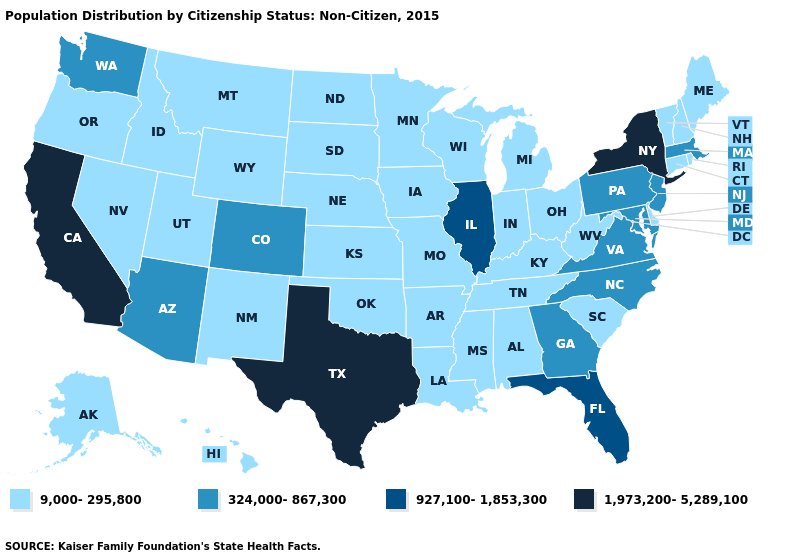Name the states that have a value in the range 9,000-295,800?
Be succinct. Alabama, Alaska, Arkansas, Connecticut, Delaware, Hawaii, Idaho, Indiana, Iowa, Kansas, Kentucky, Louisiana, Maine, Michigan, Minnesota, Mississippi, Missouri, Montana, Nebraska, Nevada, New Hampshire, New Mexico, North Dakota, Ohio, Oklahoma, Oregon, Rhode Island, South Carolina, South Dakota, Tennessee, Utah, Vermont, West Virginia, Wisconsin, Wyoming. Does Colorado have the same value as Arkansas?
Keep it brief. No. Which states have the highest value in the USA?
Keep it brief. California, New York, Texas. Does Pennsylvania have a higher value than Colorado?
Answer briefly. No. Name the states that have a value in the range 324,000-867,300?
Be succinct. Arizona, Colorado, Georgia, Maryland, Massachusetts, New Jersey, North Carolina, Pennsylvania, Virginia, Washington. Name the states that have a value in the range 9,000-295,800?
Keep it brief. Alabama, Alaska, Arkansas, Connecticut, Delaware, Hawaii, Idaho, Indiana, Iowa, Kansas, Kentucky, Louisiana, Maine, Michigan, Minnesota, Mississippi, Missouri, Montana, Nebraska, Nevada, New Hampshire, New Mexico, North Dakota, Ohio, Oklahoma, Oregon, Rhode Island, South Carolina, South Dakota, Tennessee, Utah, Vermont, West Virginia, Wisconsin, Wyoming. Name the states that have a value in the range 1,973,200-5,289,100?
Concise answer only. California, New York, Texas. Does Illinois have the lowest value in the MidWest?
Short answer required. No. Is the legend a continuous bar?
Write a very short answer. No. Does North Carolina have the lowest value in the USA?
Give a very brief answer. No. Name the states that have a value in the range 324,000-867,300?
Give a very brief answer. Arizona, Colorado, Georgia, Maryland, Massachusetts, New Jersey, North Carolina, Pennsylvania, Virginia, Washington. What is the value of Delaware?
Give a very brief answer. 9,000-295,800. Name the states that have a value in the range 1,973,200-5,289,100?
Answer briefly. California, New York, Texas. Does Tennessee have a lower value than Indiana?
Give a very brief answer. No. 